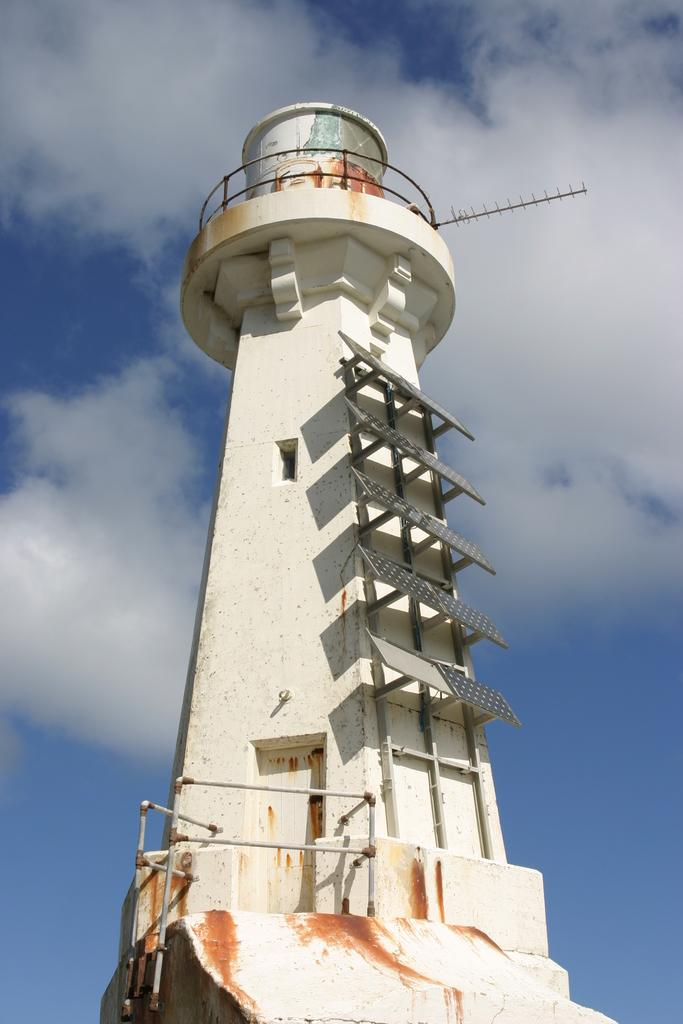What is the main structure in the picture? There is a tower in the picture. What features can be seen on the tower? The tower has solar panels and an antenna. What is visible at the top of the picture? The sky is visible at the top of the picture. Are the brothers fighting in the picture? There is no reference to brothers or fighting in the image, so it cannot be determined from the picture. 